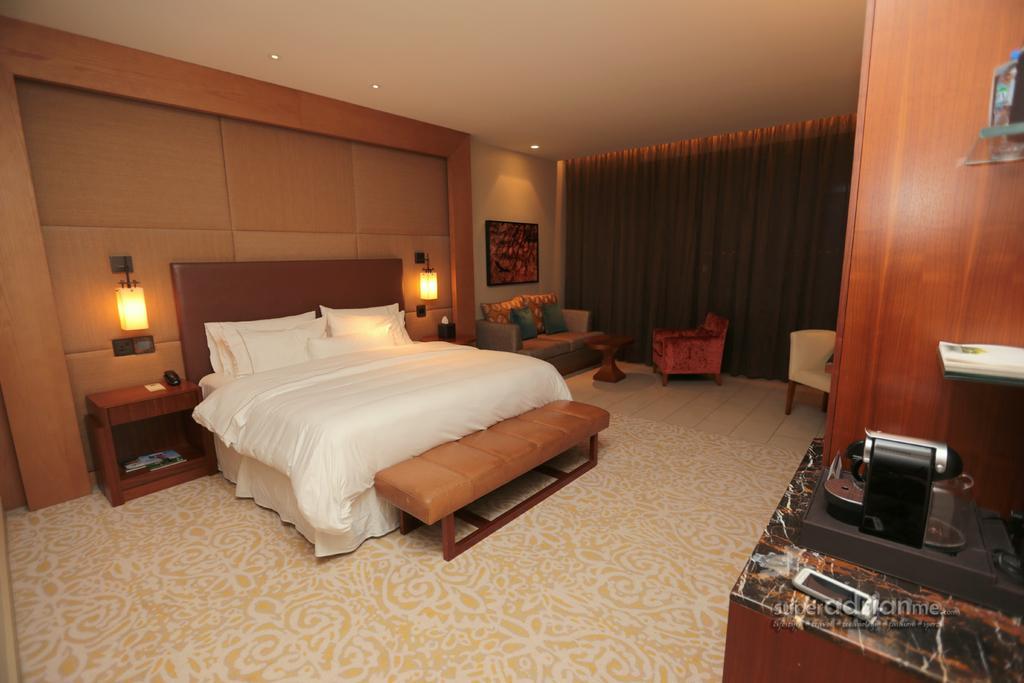Please provide a concise description of this image. In this picture I can see a bed with blankets and pillows, there are chairs, lights, there is a frame attached to the wall, there is a couch, there are some objects on the tables and on the glass shelves, there is a carpet, there is a mobile on the table, and there is a watermark on the image. 